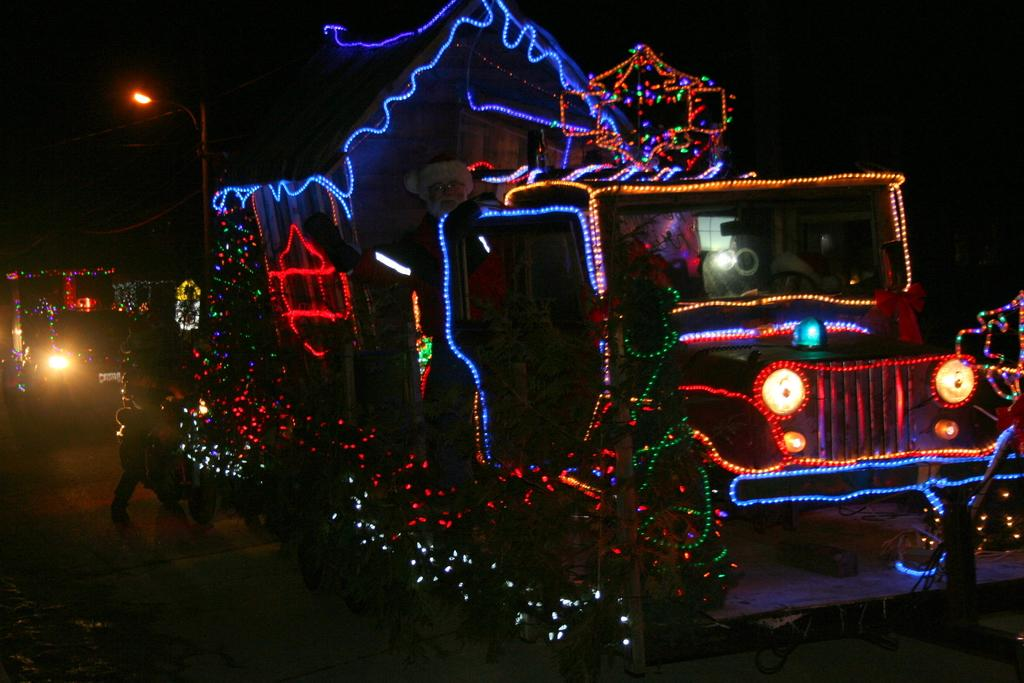What type of vehicle is decorated with lights in the image? There is a vehicle decorated with lights in the image. Are there any other vehicles visible in the image? Yes, there are other vehicles behind the decorated vehicle. What can be seen in the background of the image? There is a street light in the background of the image. What type of cream is being used to mark the carriage in the image? There is no carriage or cream present in the image. 